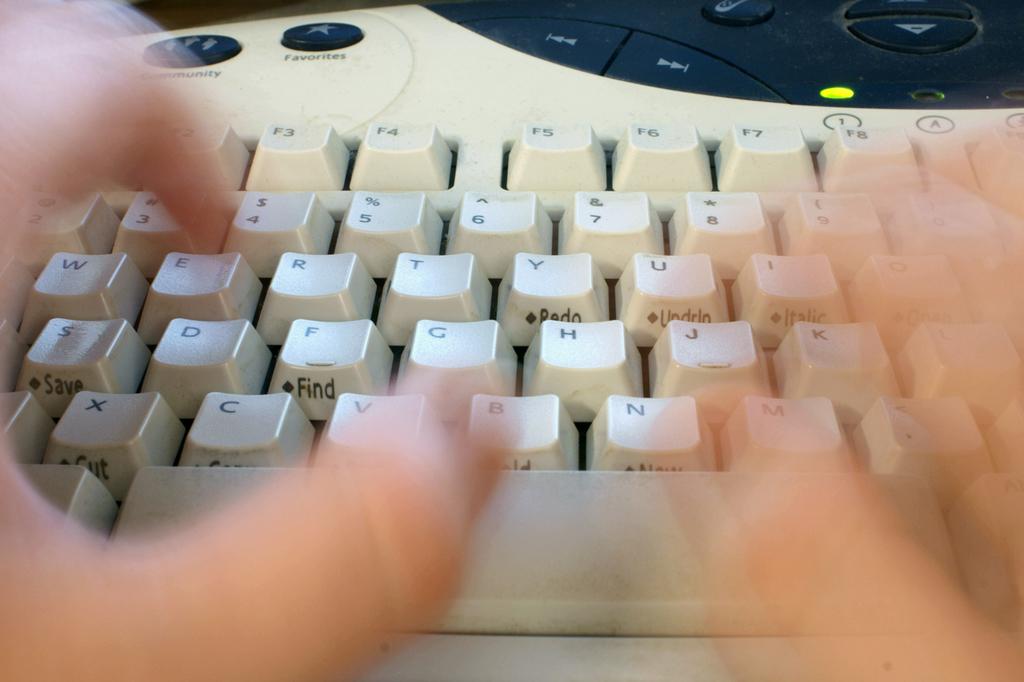What word can be seen under the f key?
Provide a succinct answer. Find. What is the key to the right of t?
Your answer should be compact. Y. 